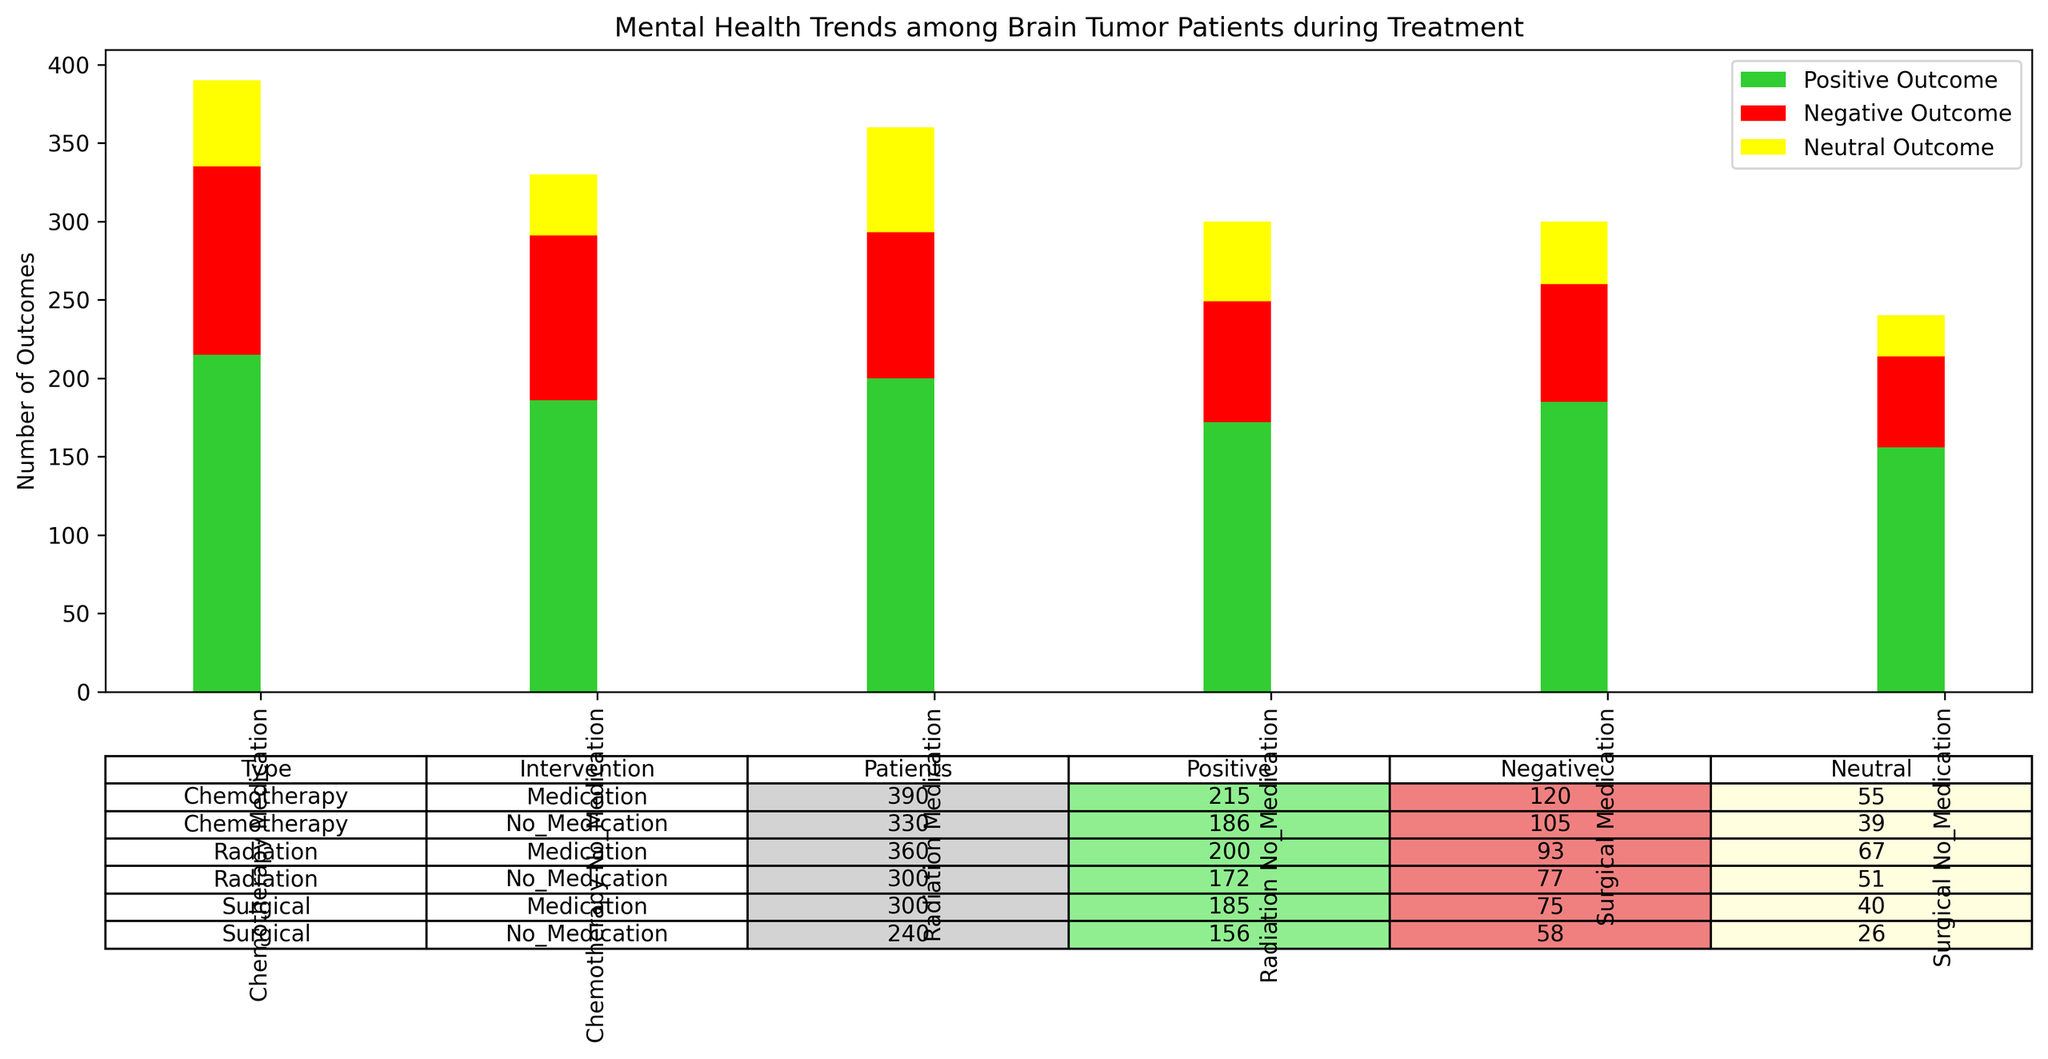Which type and intervention had the highest number of positive outcomes? First, look at the segments representing positive outcomes (green bars). Then, compare their heights across all types and interventions. Identify the combination with the tallest green bar.
Answer: Chemotherapy, Medication Between Chemotherapy with Medication and Surgical with No Medication, which has more negative outcomes? Compare the red segments of these two types and interventions. Count or visually estimate the height of the red bars to see which has a higher count.
Answer: Chemotherapy, Medication How does the number of neutral outcomes compare between Radiation with Family Support and Surgical with Family Support? Look at the yellow segments for both types with Family Support. Compare the heights visually to determine which is taller.
Answer: Radiation with Family Support has more neutral outcomes What is the total number of outcomes for Radiation, No Medication with Support Group? Sum the counts of positive (52), negative (22), and neutral outcomes (21) for Radiation, No Medication with Support Group.
Answer: 95 Which intervention method shows the least variation in mental health outcomes across all types? To find this, compare the height differences among positive (green), negative (red), and neutral (yellow) segments across all types and interventions. The least variation method has the most uniform segment heights.
Answer: No Medication Which type of treatment has the overall highest number of patients experiencing positive outcomes? Aggregate the positive outcomes across all interventions for each type. Compare these sums and identify the highest.
Answer: Chemotherapy Is there any type where Family Support consistently shows better mental health outcomes than other support methods? Examine the green bars associated with Family Support across all treatment types. Compare their heights with those of Counseling and Support Group within the same interventions.
Answer: Yes, in most cases How do the negative outcomes for Surgical with Medication compare to those for Radiation with Medication? Compare the red segments’ heights or counts between Surgical with Medication and Radiation with Medication.
Answer: Radiation with Medication has more negative outcomes Which support method under Radiation without Medication results in the highest positive outcomes? Look for Radiation without Medication and compare the green segments for Counseling, Support Group, and Family Support.
Answer: Family Support What is the difference in the number of positive outcomes between Chemotherapy with Family Support and Chemotherapy with Counseling? Subtract the positive outcomes of Chemotherapy with Counseling (70) from those of Chemotherapy with Family Support (80).
Answer: 10 